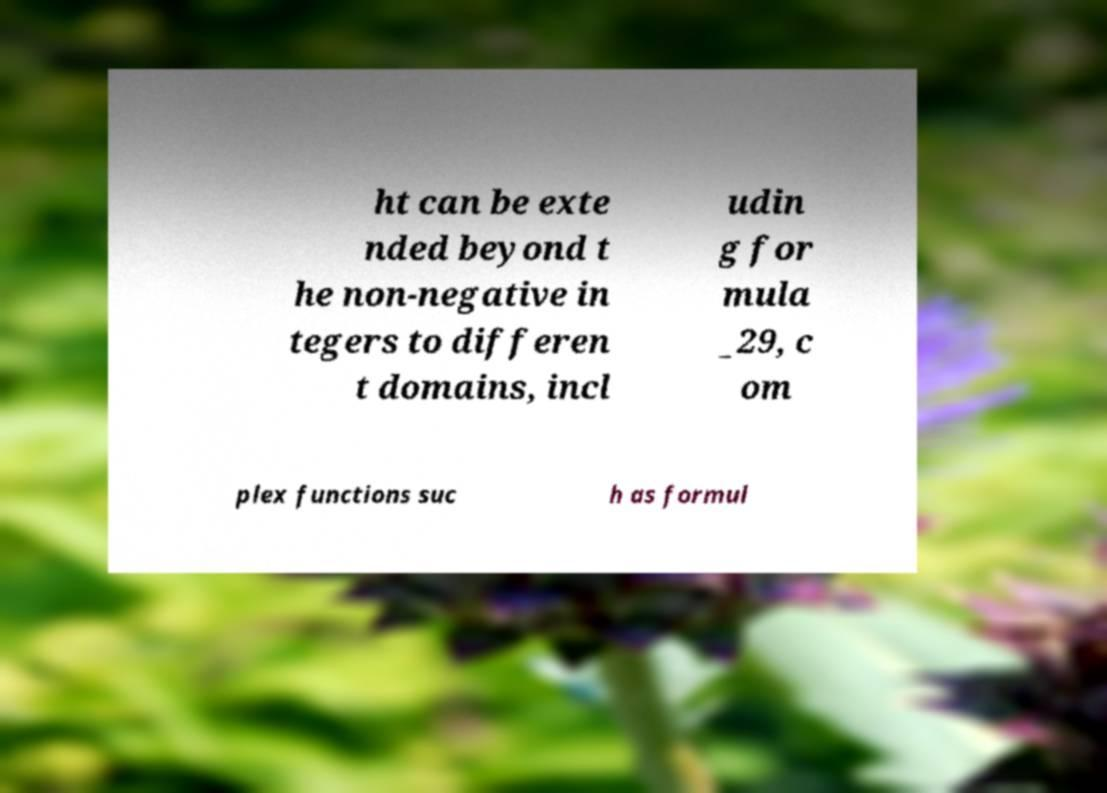Can you read and provide the text displayed in the image?This photo seems to have some interesting text. Can you extract and type it out for me? ht can be exte nded beyond t he non-negative in tegers to differen t domains, incl udin g for mula _29, c om plex functions suc h as formul 